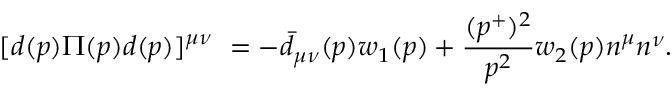<formula> <loc_0><loc_0><loc_500><loc_500>[ d ( p ) \Pi ( p ) d ( p ) ] ^ { \mu \nu } = - { \bar { d } } _ { \mu \nu } ( p ) w _ { 1 } ( p ) + { \frac { ( p ^ { + } ) ^ { 2 } } { p ^ { 2 } } } w _ { 2 } ( p ) n ^ { \mu } n ^ { \nu } .</formula> 